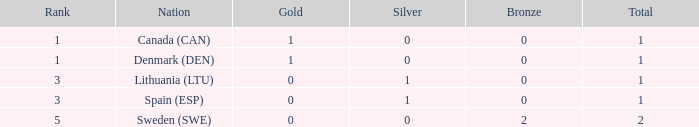What is the rank when there was less than 1 gold, 0 bronze, and more than 1 total? None. 